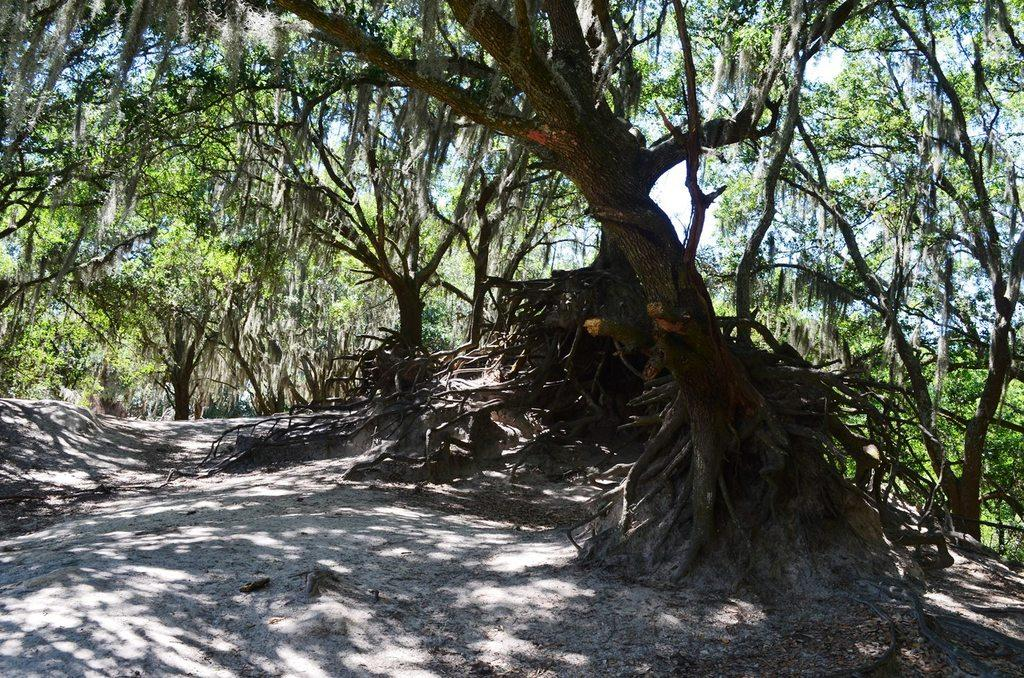What is in the foreground of the picture? There is soil in the foreground of the picture. What can be seen in the central part of the picture? There are trees in the central part of the picture. What part of the trees is visible in the image? The roots of the trees are visible. What is the weather like in the image? The image appears to be taken on a sunny day. How many trucks are parked near the trees in the image? There are no trucks present in the image. 